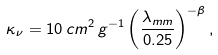Convert formula to latex. <formula><loc_0><loc_0><loc_500><loc_500>\kappa _ { \nu } = 1 0 \, c m ^ { 2 } \, g ^ { - 1 } \left ( \frac { \lambda _ { m m } } { 0 . 2 5 } \right ) ^ { - \beta } ,</formula> 